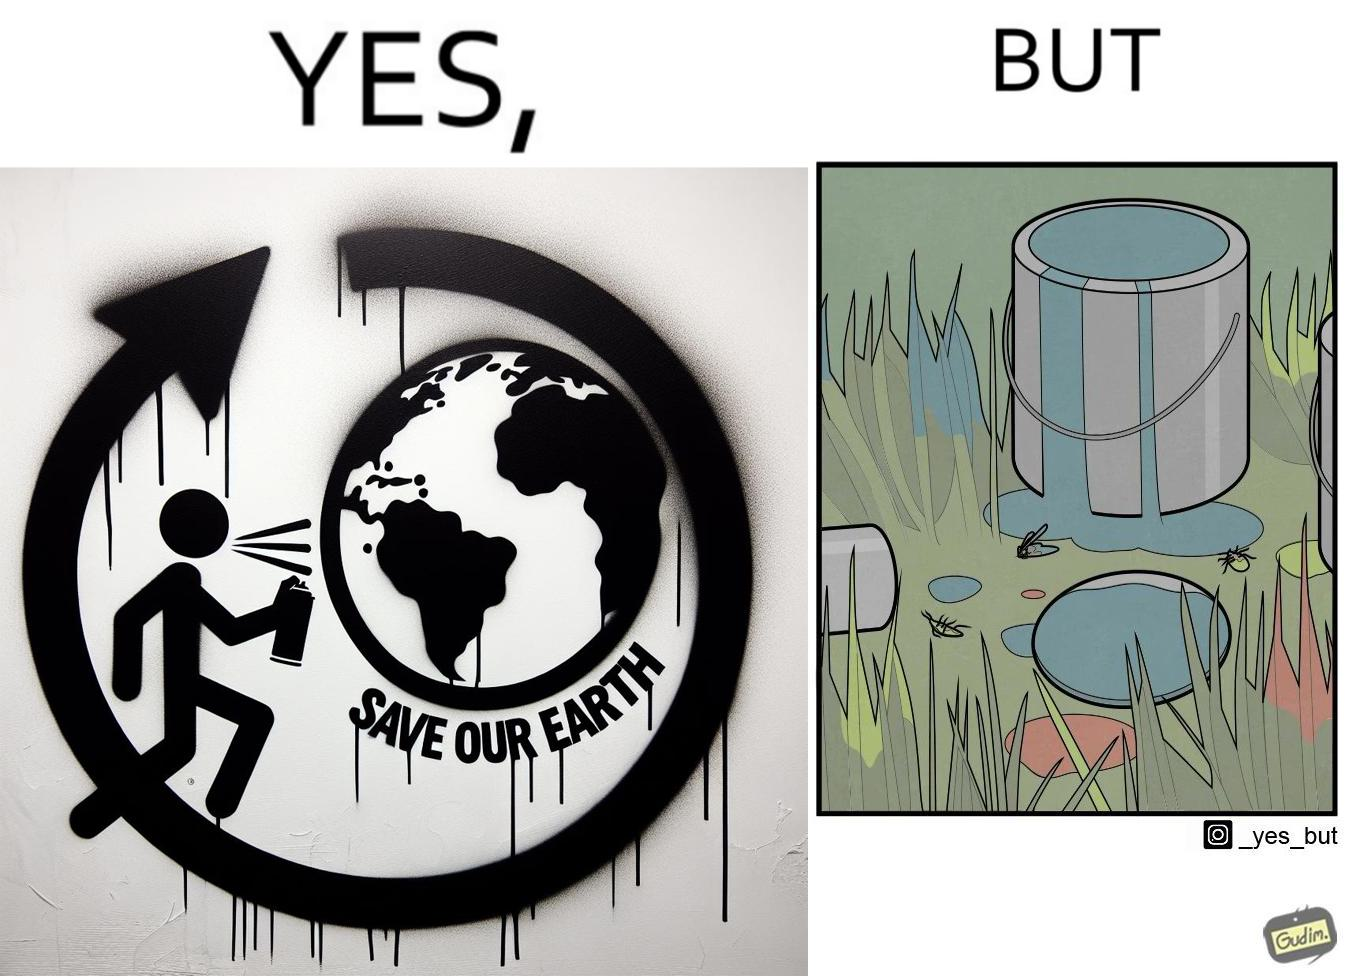What makes this image funny or satirical? The image is ironical, as the cans of paint used to make graffiti on the theme "Save the Earth" seems to be destroying the Earth when it overflows on the grass, as it is harmful for the flora and fauna, as can be seen from the dying insects. 